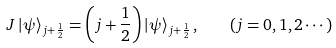Convert formula to latex. <formula><loc_0><loc_0><loc_500><loc_500>J \left | \psi \right \rangle _ { j + \frac { 1 } { 2 } } = \left ( j + \frac { 1 } { 2 } \right ) \left | \psi \right \rangle _ { j + \frac { 1 } { 2 } } , \quad \left ( j = 0 , 1 , 2 \cdots \right )</formula> 